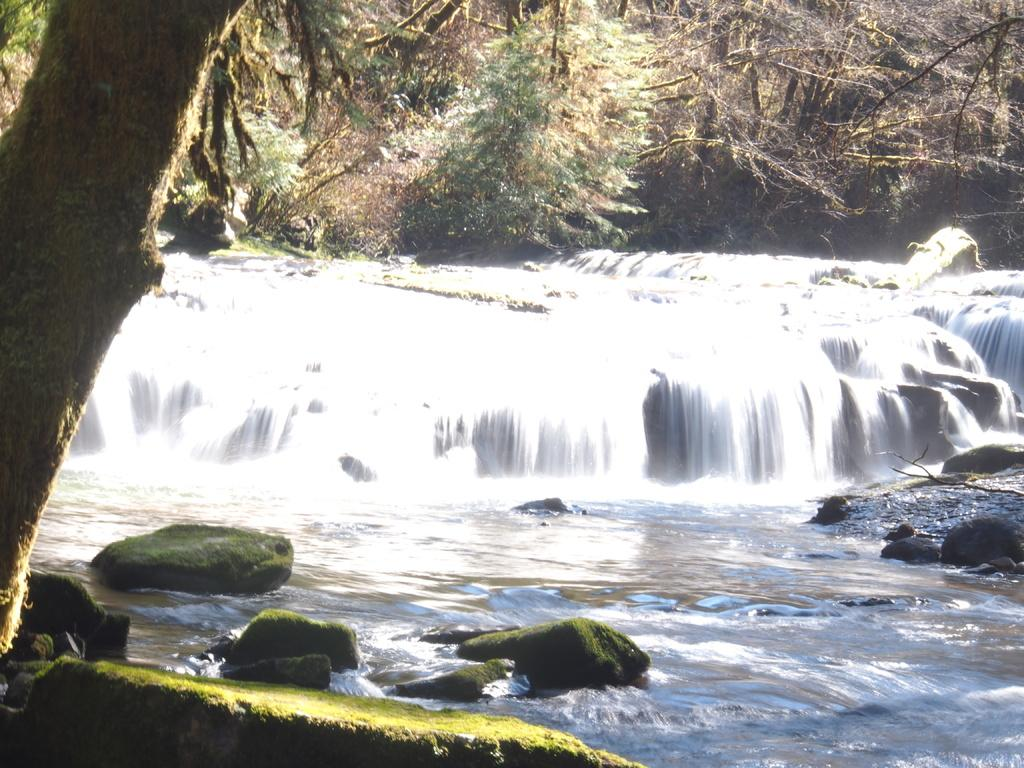What type of natural vegetation is present in the image? There are trees in the image. What type of geological formation can be seen in the image? There are rocks in the image. What type of water feature is present in the image? There are waterfalls in the image. Where is the jar of science supplies located in the image? There is no jar or science supplies present in the image. What type of house is visible in the image? There is no house visible in the image. 